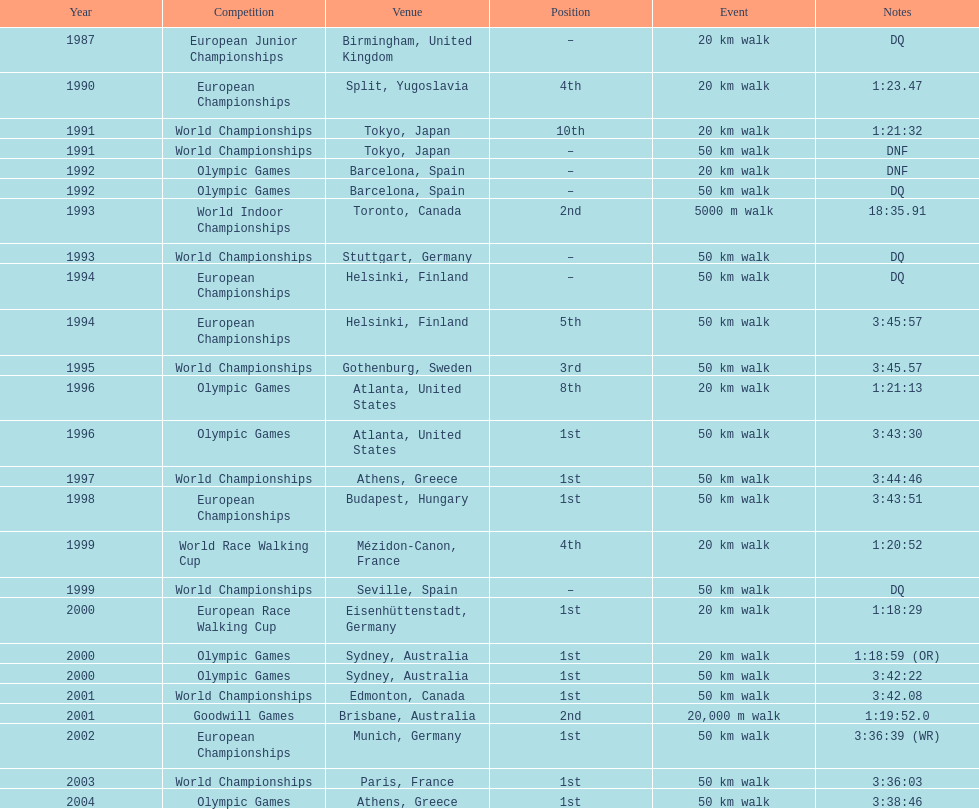In 1996, what event transpired before the olympic games and what was its name? World Championships. 